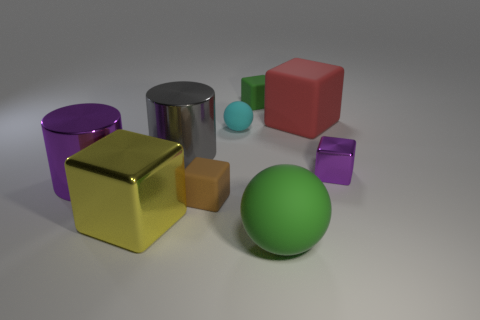Does the gray metallic object have the same size as the purple cube?
Provide a succinct answer. No. What number of things are yellow cubes or small green objects?
Ensure brevity in your answer.  2. There is a rubber thing that is right of the cyan matte object and in front of the gray cylinder; how big is it?
Give a very brief answer. Large. Are there fewer big gray metal cylinders that are in front of the big matte sphere than large purple things?
Give a very brief answer. Yes. The tiny purple object that is the same material as the big yellow object is what shape?
Give a very brief answer. Cube. Does the large rubber thing on the right side of the green matte sphere have the same shape as the large rubber thing that is in front of the brown matte cube?
Your answer should be very brief. No. Are there fewer tiny matte blocks left of the big gray cylinder than red things that are to the left of the yellow shiny object?
Provide a succinct answer. No. There is a thing that is the same color as the small shiny cube; what shape is it?
Make the answer very short. Cylinder. How many red things have the same size as the green rubber ball?
Provide a short and direct response. 1. Is the material of the big cube on the left side of the big gray metal cylinder the same as the tiny sphere?
Your response must be concise. No. 